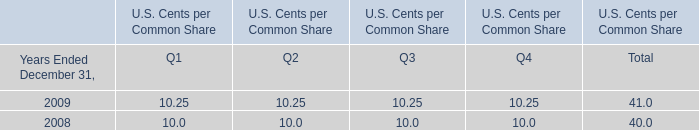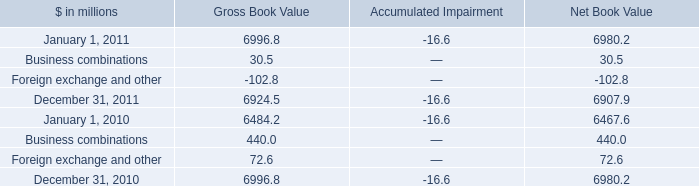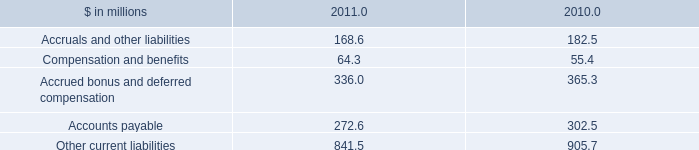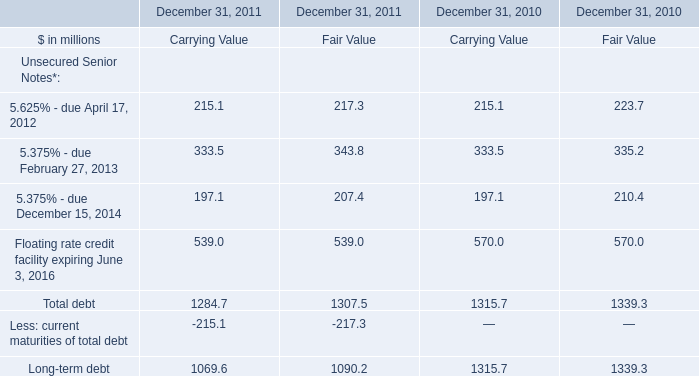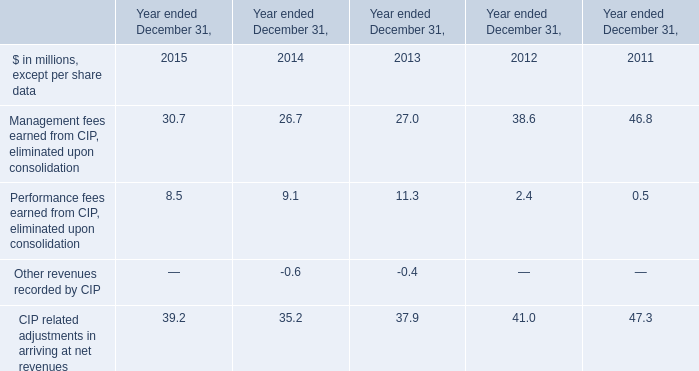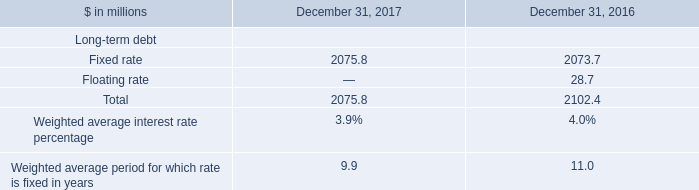What was the total amount of 5.625% - due April 17, 2012 in 2011? (in million) 
Computations: (215.1 + 217.3)
Answer: 432.4. 